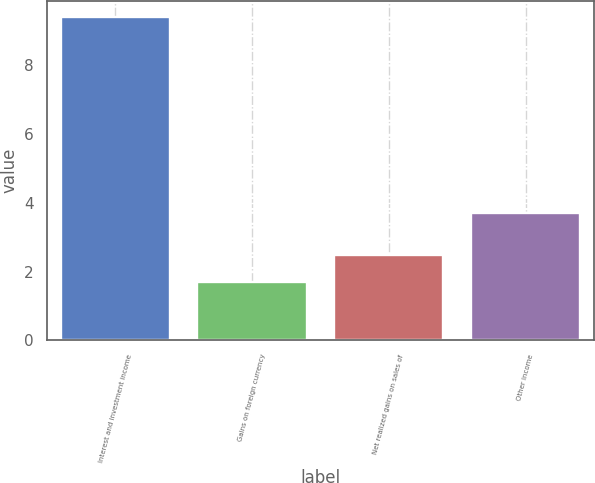Convert chart to OTSL. <chart><loc_0><loc_0><loc_500><loc_500><bar_chart><fcel>Interest and investment income<fcel>Gains on foreign currency<fcel>Net realized gains on sales of<fcel>Other income<nl><fcel>9.4<fcel>1.7<fcel>2.47<fcel>3.7<nl></chart> 